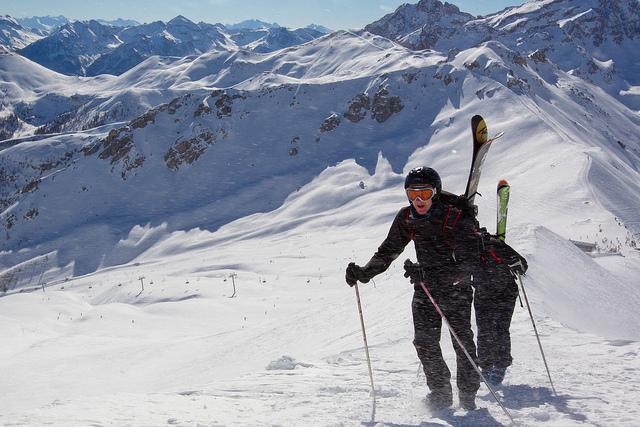How many people are in the snow?
Give a very brief answer. 2. How many people are in the photo?
Give a very brief answer. 2. How many giraffes are facing to the right?
Give a very brief answer. 0. 